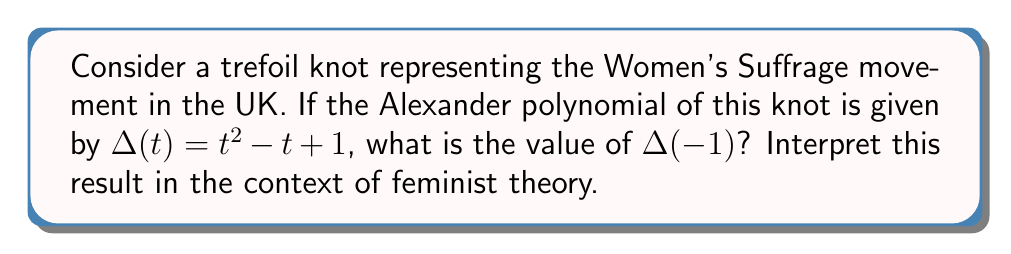Can you solve this math problem? To solve this problem, we'll follow these steps:

1) We are given the Alexander polynomial for the trefoil knot:
   $$\Delta(t) = t^2 - t + 1$$

2) We need to calculate $\Delta(-1)$, which means substituting $t = -1$ into the polynomial:
   $$\Delta(-1) = (-1)^2 - (-1) + 1$$

3) Let's evaluate each term:
   - $(-1)^2 = 1$
   - $-(-1) = 1$
   - $1$ remains as 1

4) Now we can add these terms:
   $$\Delta(-1) = 1 + 1 + 1 = 3$$

5) Interpretation in feminist theory:
   The value 3 is significant in knot theory as it represents the number of crossings in a trefoil knot. In the context of the Women's Suffrage movement, this can be interpreted as representing the three main waves of feminism:
   - First wave: Focused on suffrage and legal rights (late 19th/early 20th century)
   - Second wave: Broadened debate to sexuality, family, workplace, and reproductive rights (1960s-1980s)
   - Third wave: Continued to address social and cultural inequalities (1990s-present)

   Just as the trefoil knot is the simplest non-trivial knot, these three waves form the fundamental structure of the feminist movement, intertwined and inseparable.
Answer: $\Delta(-1) = 3$, representing the three main waves of feminism. 